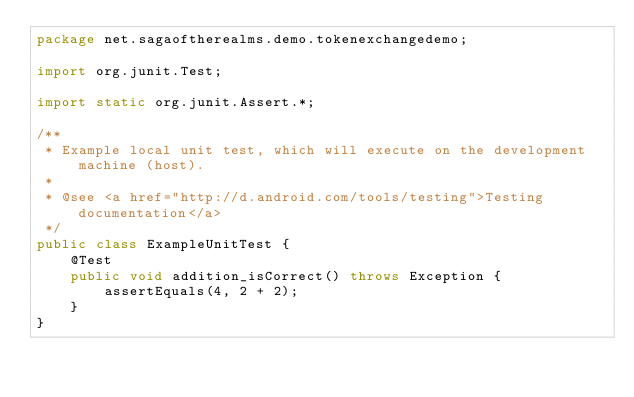<code> <loc_0><loc_0><loc_500><loc_500><_Java_>package net.sagaoftherealms.demo.tokenexchangedemo;

import org.junit.Test;

import static org.junit.Assert.*;

/**
 * Example local unit test, which will execute on the development machine (host).
 *
 * @see <a href="http://d.android.com/tools/testing">Testing documentation</a>
 */
public class ExampleUnitTest {
    @Test
    public void addition_isCorrect() throws Exception {
        assertEquals(4, 2 + 2);
    }
}</code> 